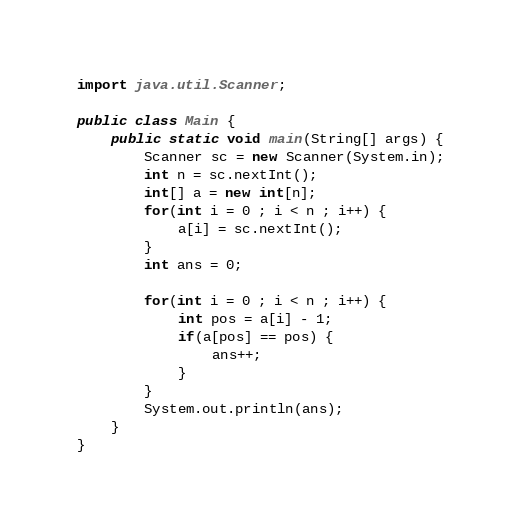<code> <loc_0><loc_0><loc_500><loc_500><_Java_>import java.util.Scanner;

public class Main {
	public static void main(String[] args) {
		Scanner sc = new Scanner(System.in);
		int n = sc.nextInt();
		int[] a = new int[n];
		for(int i = 0 ; i < n ; i++) {
			a[i] = sc.nextInt();
		}
		int ans = 0;

		for(int i = 0 ; i < n ; i++) {
			int pos = a[i] - 1;
			if(a[pos] == pos) {
				ans++;
			}
		}
		System.out.println(ans);
	}
}
</code> 